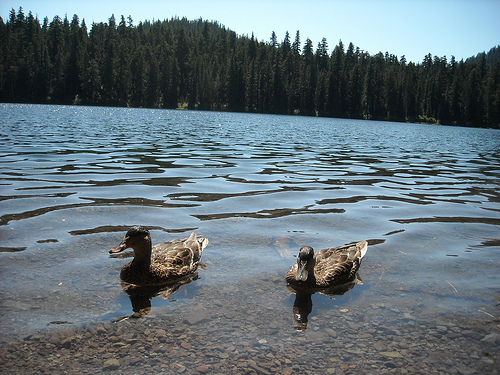<image>
Can you confirm if the duck is on the water? Yes. Looking at the image, I can see the duck is positioned on top of the water, with the water providing support. Is the duck under the water? No. The duck is not positioned under the water. The vertical relationship between these objects is different. Is the duck in the river? Yes. The duck is contained within or inside the river, showing a containment relationship. 